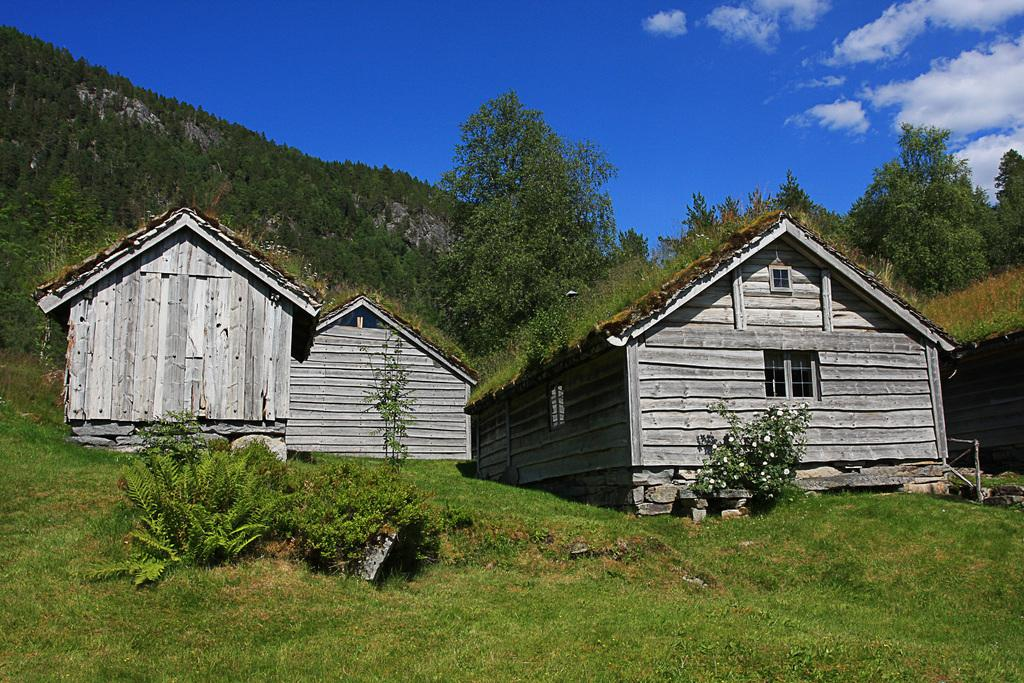What type of vegetation is present in the image? There is grass and plants in the image. What type of structures can be seen in the front of the image? There are shacks in the front of the image. What is visible in the background of the image? There are trees, clouds, and the sky visible in the background. What type of beef is being cooked on the grill in the image? There is no grill or beef present in the image. Can you tell me what color the balloon is in the image? There is no balloon present in the image. 